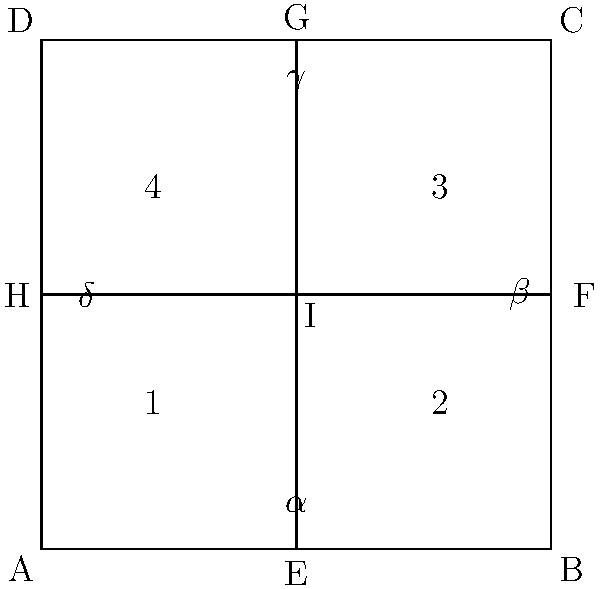In the given geometric shape, representing a moral decision-making framework, four intersecting lines form a square with diagonals. If angles $\alpha$, $\beta$, $\gamma$, and $\delta$ represent different ethical considerations, and it is known that $\alpha + \beta + \gamma + \delta = 360°$, what is the measure of each angle? How might this relate to the balance of ethical principles in deontological ethics? To solve this problem, we need to follow these steps:

1) First, observe that the figure is a square divided into four congruent triangles by its diagonals.

2) In a square, all four corners are right angles (90°).

3) The diagonals of a square bisect each other at right angles. This means that the intersection point I creates four right angles.

4) Given that $\alpha + \beta + \gamma + \delta = 360°$, and knowing that these four angles form a complete rotation around point I, we can conclude that each of these angles must be equal.

5) If four equal angles sum to 360°, then each angle must be 360° ÷ 4 = 90°.

6) Therefore, $\alpha = \beta = \gamma = \delta = 90°$.

Relating this to deontological ethics:

7) In deontological ethics, moral decisions are based on adherence to moral rules or duties, rather than consequences.

8) The equality of these angles could represent the equal importance of different moral duties or principles in deontological ethics.

9) Just as the angles maintain the structure of the square, adhering equally to all moral duties maintains the integrity of one's ethical framework.

10) However, this rigid equality might be seen as a critique of deontological ethics, as it doesn't allow for prioritization of duties in complex situations, which is often a point of criticism for this ethical system.
Answer: $\alpha = \beta = \gamma = \delta = 90°$, representing equal weight of moral duties in deontological ethics. 